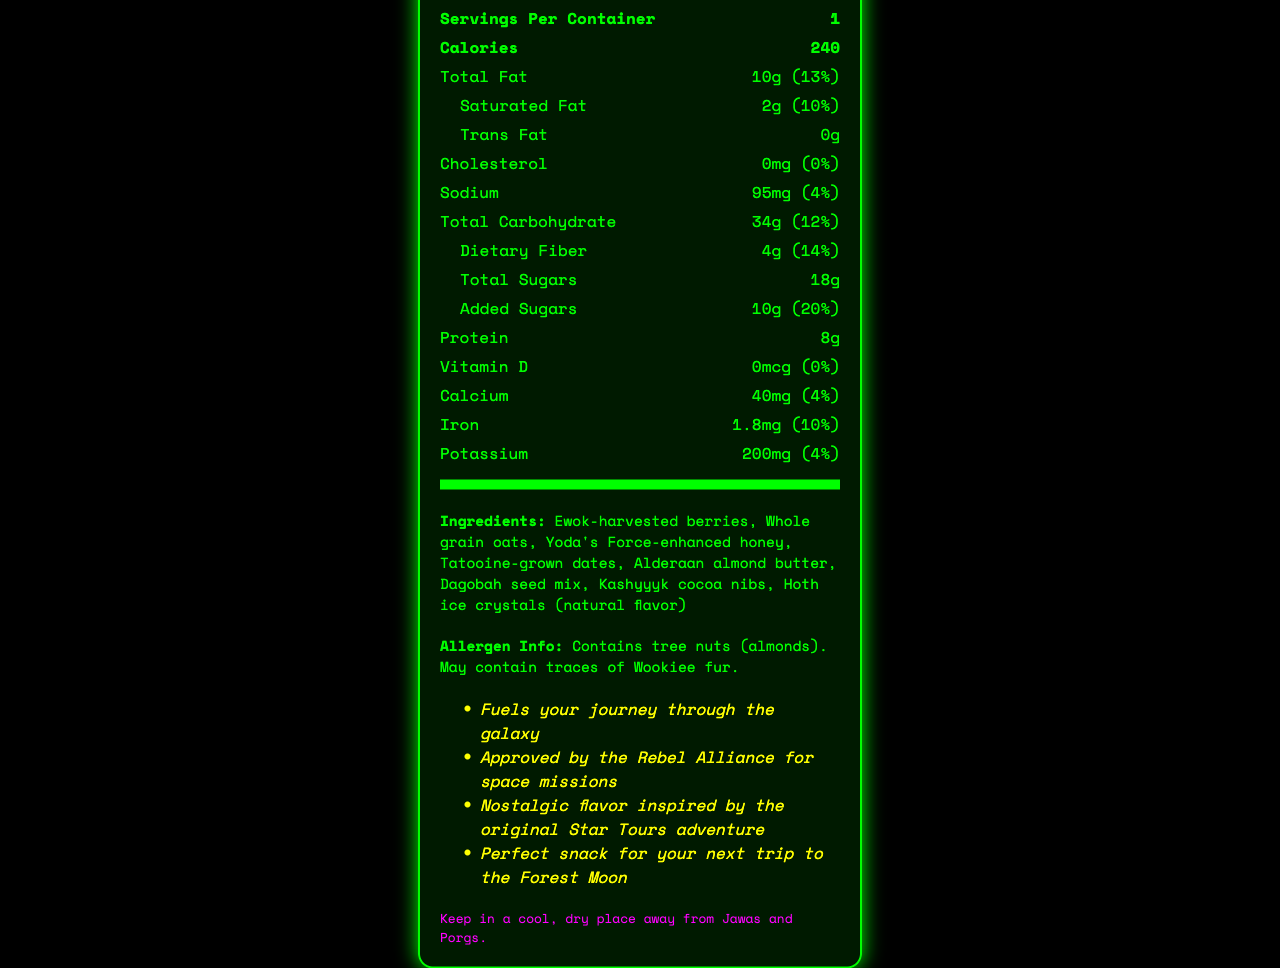what is the serving size of the Endor Forest Feast Energy Bar? The serving size is listed near the top of the nutrition label as "1 bar (60g)."
Answer: 1 bar (60g) how many calories are in one serving? The document states that there are 240 calories per serving.
Answer: 240 what is the amount of protein in the bar? The amount of protein in the bar is listed as 8g.
Answer: 8g how many grams of total sugars are there in the bar? The total sugars amount is listed as 18g.
Answer: 18g what percentage of the daily value does the iron content represent? The iron content represents 10% of the daily value, as listed next to iron.
Answer: 10% how much sodium does the bar contain? A. 40mg B. 95mg C. 150mg D. 200mg The document states that the sodium content is 95mg.
Answer: B which of the following ingredients is NOT in the Endor Forest Feast Energy Bar? I. Ewok-harvested berries II. Whole grain oats III. Coruscant corn flakes IV. Dagobah seed mix Coruscant corn flakes are not listed among the ingredients.
Answer: III is the bar suitable for someone with a tree nut allergy? The allergen information states that the bar contains tree nuts (almonds).
Answer: No What is the main idea of this document? The document includes a comprehensive overview of the energy bar's nutrition, ingredients, and advisories to help consumers make informed choices.
Answer: The document provides detailed nutrition facts and information about the Endor Forest Feast Energy Bar, including its ingredients, nutrient content, marketing claims, and storage instructions. how much vitamin D is in the bar? The vitamin D content is listed as 0mcg.
Answer: 0mcg what type of flavor does the marketing claim suggest is a nostalgic reminder? The marketing claims section mentions a "Nostalgic flavor inspired by the original Star Tours adventure."
Answer: The original Star Tours adventure by what percentage does the added sugars contribute to the daily value? The added sugars contribute 20% to the daily value as listed next to the added sugars information.
Answer: 20% what is the daily value percentage for dietary fiber in the bar? The daily value percentage for dietary fiber is 14%, as indicated in the document.
Answer: 14% what are the storage instructions for this product? The storage instructions are listed at the end of the document.
Answer: Keep in a cool, dry place away from Jawas and Porgs. who approved the energy bar for space missions? The marketing claims section states that it is "Approved by the Rebel Alliance for space missions."
Answer: The Rebel Alliance does the bar contain any trans fat? The document states that the bar contains 0g of trans fat.
Answer: No what is the calcium content per serving, and how much of the daily value does it represent? The calcium content is 40mg, representing 4% of the daily value, as listed in the document.
Answer: 40mg, 4% how many servings are there per container? The document specifies that there is 1 serving per container.
Answer: 1 how much potassium is in the bar, and what percentage of the daily value does this represent? The potassium content is listed as 200mg, representing 4% of the daily value.
Answer: 200mg, 4% does the document provide the amount of total carbohydrates in grams? The total carbohydrate content is provided as 34g.
Answer: Yes 